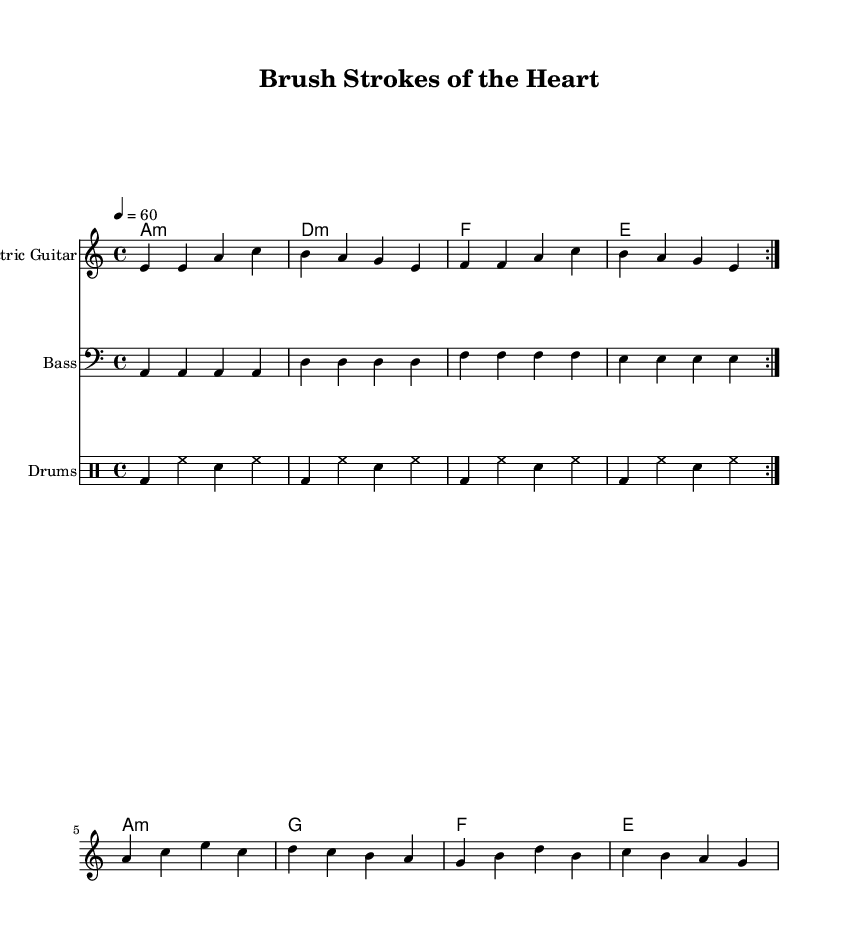What is the key signature of this music? The key signature is defined by the number of sharps or flats indicated at the beginning of the staff. This music is in A minor, which corresponds to having no sharps or flats.
Answer: A minor What is the time signature of this music? The time signature is located at the beginning of the staff, indicating how many beats are in each measure. The music shows a 4/4 time signature, meaning there are four beats per measure and the quarter note gets one beat.
Answer: 4/4 What is the tempo marking of this music? The tempo can be found specified above the staff. This music has a tempo marking of quarter note equals 60, indicating a slow pace of 60 beats per minute.
Answer: 60 Which instruments are featured in this score? The score lists different instruments denoted by their respective staves. This piece includes Electric Guitar, Bass, and Drums.
Answer: Electric Guitar, Bass, Drums How many voltas are indicated in the music? The repeat signs labeled with 'volta' indicate how many times certain sections should be repeated. This score has two voltas in the electric guitar and bass parts, showing that they should be played twice.
Answer: 2 What chord is played on the first measure of the chords? The chord names directly above the measure show the chords played. The first chord, marked in the first measure, is A minor.
Answer: A minor What musical genre does this piece belong to? The musical style can be identified through the chord progressions, rhythms, and instrumentation prevalent in the score. This piece's elements and style indicate that it belongs to the Electric Blues genre.
Answer: Electric Blues 